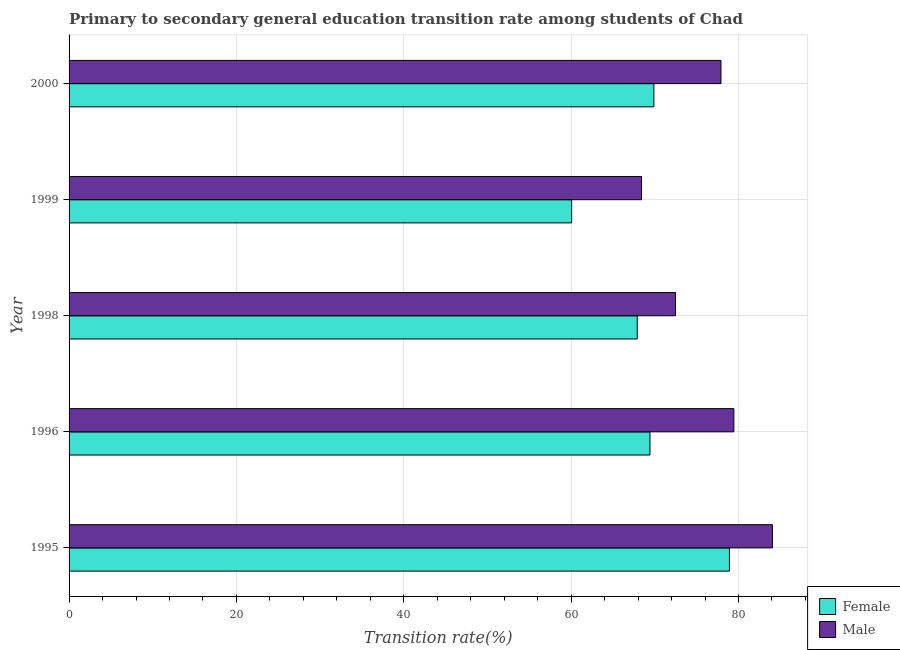How many different coloured bars are there?
Provide a short and direct response. 2. How many groups of bars are there?
Offer a terse response. 5. Are the number of bars per tick equal to the number of legend labels?
Provide a short and direct response. Yes. How many bars are there on the 2nd tick from the top?
Make the answer very short. 2. How many bars are there on the 1st tick from the bottom?
Provide a short and direct response. 2. What is the transition rate among female students in 1995?
Give a very brief answer. 78.92. Across all years, what is the maximum transition rate among female students?
Offer a terse response. 78.92. Across all years, what is the minimum transition rate among female students?
Your response must be concise. 60.06. In which year was the transition rate among male students maximum?
Your response must be concise. 1995. In which year was the transition rate among male students minimum?
Keep it short and to the point. 1999. What is the total transition rate among female students in the graph?
Offer a very short reply. 346.19. What is the difference between the transition rate among female students in 1995 and that in 1996?
Your response must be concise. 9.49. What is the difference between the transition rate among female students in 1996 and the transition rate among male students in 1999?
Offer a very short reply. 1.01. What is the average transition rate among female students per year?
Offer a very short reply. 69.24. In the year 1996, what is the difference between the transition rate among female students and transition rate among male students?
Your answer should be compact. -10.03. In how many years, is the transition rate among female students greater than 80 %?
Your answer should be very brief. 0. What is the ratio of the transition rate among female students in 1996 to that in 1998?
Make the answer very short. 1.02. What is the difference between the highest and the second highest transition rate among female students?
Make the answer very short. 9.03. What is the difference between the highest and the lowest transition rate among female students?
Give a very brief answer. 18.86. What does the 2nd bar from the top in 1998 represents?
Your response must be concise. Female. What does the 1st bar from the bottom in 1998 represents?
Your answer should be compact. Female. Are all the bars in the graph horizontal?
Your answer should be compact. Yes. How many years are there in the graph?
Your answer should be very brief. 5. Does the graph contain any zero values?
Ensure brevity in your answer.  No. Does the graph contain grids?
Make the answer very short. Yes. Where does the legend appear in the graph?
Keep it short and to the point. Bottom right. How many legend labels are there?
Make the answer very short. 2. What is the title of the graph?
Offer a very short reply. Primary to secondary general education transition rate among students of Chad. Does "Commercial service imports" appear as one of the legend labels in the graph?
Offer a very short reply. No. What is the label or title of the X-axis?
Provide a succinct answer. Transition rate(%). What is the label or title of the Y-axis?
Give a very brief answer. Year. What is the Transition rate(%) of Female in 1995?
Your response must be concise. 78.92. What is the Transition rate(%) of Male in 1995?
Make the answer very short. 84.06. What is the Transition rate(%) in Female in 1996?
Your response must be concise. 69.42. What is the Transition rate(%) of Male in 1996?
Offer a terse response. 79.45. What is the Transition rate(%) of Female in 1998?
Provide a succinct answer. 67.9. What is the Transition rate(%) of Male in 1998?
Your answer should be very brief. 72.47. What is the Transition rate(%) of Female in 1999?
Offer a terse response. 60.06. What is the Transition rate(%) of Male in 1999?
Offer a terse response. 68.41. What is the Transition rate(%) in Female in 2000?
Your answer should be compact. 69.89. What is the Transition rate(%) of Male in 2000?
Your answer should be compact. 77.91. Across all years, what is the maximum Transition rate(%) of Female?
Provide a short and direct response. 78.92. Across all years, what is the maximum Transition rate(%) in Male?
Your answer should be compact. 84.06. Across all years, what is the minimum Transition rate(%) of Female?
Provide a short and direct response. 60.06. Across all years, what is the minimum Transition rate(%) of Male?
Offer a terse response. 68.41. What is the total Transition rate(%) in Female in the graph?
Your answer should be compact. 346.19. What is the total Transition rate(%) in Male in the graph?
Provide a succinct answer. 382.29. What is the difference between the Transition rate(%) of Female in 1995 and that in 1996?
Offer a terse response. 9.5. What is the difference between the Transition rate(%) of Male in 1995 and that in 1996?
Provide a succinct answer. 4.61. What is the difference between the Transition rate(%) in Female in 1995 and that in 1998?
Make the answer very short. 11.02. What is the difference between the Transition rate(%) of Male in 1995 and that in 1998?
Your answer should be very brief. 11.58. What is the difference between the Transition rate(%) in Female in 1995 and that in 1999?
Offer a terse response. 18.86. What is the difference between the Transition rate(%) of Male in 1995 and that in 1999?
Make the answer very short. 15.64. What is the difference between the Transition rate(%) in Female in 1995 and that in 2000?
Your answer should be very brief. 9.03. What is the difference between the Transition rate(%) of Male in 1995 and that in 2000?
Give a very brief answer. 6.15. What is the difference between the Transition rate(%) of Female in 1996 and that in 1998?
Give a very brief answer. 1.52. What is the difference between the Transition rate(%) of Male in 1996 and that in 1998?
Offer a very short reply. 6.98. What is the difference between the Transition rate(%) of Female in 1996 and that in 1999?
Ensure brevity in your answer.  9.36. What is the difference between the Transition rate(%) in Male in 1996 and that in 1999?
Provide a short and direct response. 11.03. What is the difference between the Transition rate(%) in Female in 1996 and that in 2000?
Keep it short and to the point. -0.47. What is the difference between the Transition rate(%) of Male in 1996 and that in 2000?
Your answer should be compact. 1.54. What is the difference between the Transition rate(%) in Female in 1998 and that in 1999?
Ensure brevity in your answer.  7.84. What is the difference between the Transition rate(%) in Male in 1998 and that in 1999?
Ensure brevity in your answer.  4.06. What is the difference between the Transition rate(%) of Female in 1998 and that in 2000?
Keep it short and to the point. -1.99. What is the difference between the Transition rate(%) in Male in 1998 and that in 2000?
Provide a succinct answer. -5.44. What is the difference between the Transition rate(%) in Female in 1999 and that in 2000?
Provide a succinct answer. -9.83. What is the difference between the Transition rate(%) of Male in 1999 and that in 2000?
Offer a terse response. -9.49. What is the difference between the Transition rate(%) in Female in 1995 and the Transition rate(%) in Male in 1996?
Provide a short and direct response. -0.53. What is the difference between the Transition rate(%) in Female in 1995 and the Transition rate(%) in Male in 1998?
Provide a succinct answer. 6.45. What is the difference between the Transition rate(%) of Female in 1995 and the Transition rate(%) of Male in 1999?
Your answer should be very brief. 10.5. What is the difference between the Transition rate(%) of Female in 1995 and the Transition rate(%) of Male in 2000?
Your answer should be very brief. 1.01. What is the difference between the Transition rate(%) of Female in 1996 and the Transition rate(%) of Male in 1998?
Offer a terse response. -3.05. What is the difference between the Transition rate(%) of Female in 1996 and the Transition rate(%) of Male in 1999?
Your response must be concise. 1.01. What is the difference between the Transition rate(%) of Female in 1996 and the Transition rate(%) of Male in 2000?
Offer a terse response. -8.48. What is the difference between the Transition rate(%) in Female in 1998 and the Transition rate(%) in Male in 1999?
Offer a very short reply. -0.51. What is the difference between the Transition rate(%) of Female in 1998 and the Transition rate(%) of Male in 2000?
Offer a very short reply. -10. What is the difference between the Transition rate(%) of Female in 1999 and the Transition rate(%) of Male in 2000?
Keep it short and to the point. -17.85. What is the average Transition rate(%) of Female per year?
Offer a very short reply. 69.24. What is the average Transition rate(%) of Male per year?
Keep it short and to the point. 76.46. In the year 1995, what is the difference between the Transition rate(%) of Female and Transition rate(%) of Male?
Ensure brevity in your answer.  -5.14. In the year 1996, what is the difference between the Transition rate(%) of Female and Transition rate(%) of Male?
Your answer should be compact. -10.03. In the year 1998, what is the difference between the Transition rate(%) in Female and Transition rate(%) in Male?
Your answer should be compact. -4.57. In the year 1999, what is the difference between the Transition rate(%) in Female and Transition rate(%) in Male?
Offer a terse response. -8.35. In the year 2000, what is the difference between the Transition rate(%) in Female and Transition rate(%) in Male?
Your answer should be compact. -8.02. What is the ratio of the Transition rate(%) in Female in 1995 to that in 1996?
Keep it short and to the point. 1.14. What is the ratio of the Transition rate(%) of Male in 1995 to that in 1996?
Your response must be concise. 1.06. What is the ratio of the Transition rate(%) of Female in 1995 to that in 1998?
Offer a terse response. 1.16. What is the ratio of the Transition rate(%) of Male in 1995 to that in 1998?
Offer a terse response. 1.16. What is the ratio of the Transition rate(%) in Female in 1995 to that in 1999?
Offer a very short reply. 1.31. What is the ratio of the Transition rate(%) in Male in 1995 to that in 1999?
Keep it short and to the point. 1.23. What is the ratio of the Transition rate(%) of Female in 1995 to that in 2000?
Keep it short and to the point. 1.13. What is the ratio of the Transition rate(%) in Male in 1995 to that in 2000?
Your response must be concise. 1.08. What is the ratio of the Transition rate(%) in Female in 1996 to that in 1998?
Make the answer very short. 1.02. What is the ratio of the Transition rate(%) of Male in 1996 to that in 1998?
Keep it short and to the point. 1.1. What is the ratio of the Transition rate(%) of Female in 1996 to that in 1999?
Your answer should be compact. 1.16. What is the ratio of the Transition rate(%) in Male in 1996 to that in 1999?
Your response must be concise. 1.16. What is the ratio of the Transition rate(%) in Male in 1996 to that in 2000?
Provide a succinct answer. 1.02. What is the ratio of the Transition rate(%) in Female in 1998 to that in 1999?
Provide a succinct answer. 1.13. What is the ratio of the Transition rate(%) of Male in 1998 to that in 1999?
Offer a terse response. 1.06. What is the ratio of the Transition rate(%) of Female in 1998 to that in 2000?
Offer a terse response. 0.97. What is the ratio of the Transition rate(%) of Male in 1998 to that in 2000?
Provide a succinct answer. 0.93. What is the ratio of the Transition rate(%) of Female in 1999 to that in 2000?
Provide a succinct answer. 0.86. What is the ratio of the Transition rate(%) of Male in 1999 to that in 2000?
Offer a very short reply. 0.88. What is the difference between the highest and the second highest Transition rate(%) in Female?
Your response must be concise. 9.03. What is the difference between the highest and the second highest Transition rate(%) of Male?
Your answer should be very brief. 4.61. What is the difference between the highest and the lowest Transition rate(%) of Female?
Provide a short and direct response. 18.86. What is the difference between the highest and the lowest Transition rate(%) of Male?
Make the answer very short. 15.64. 